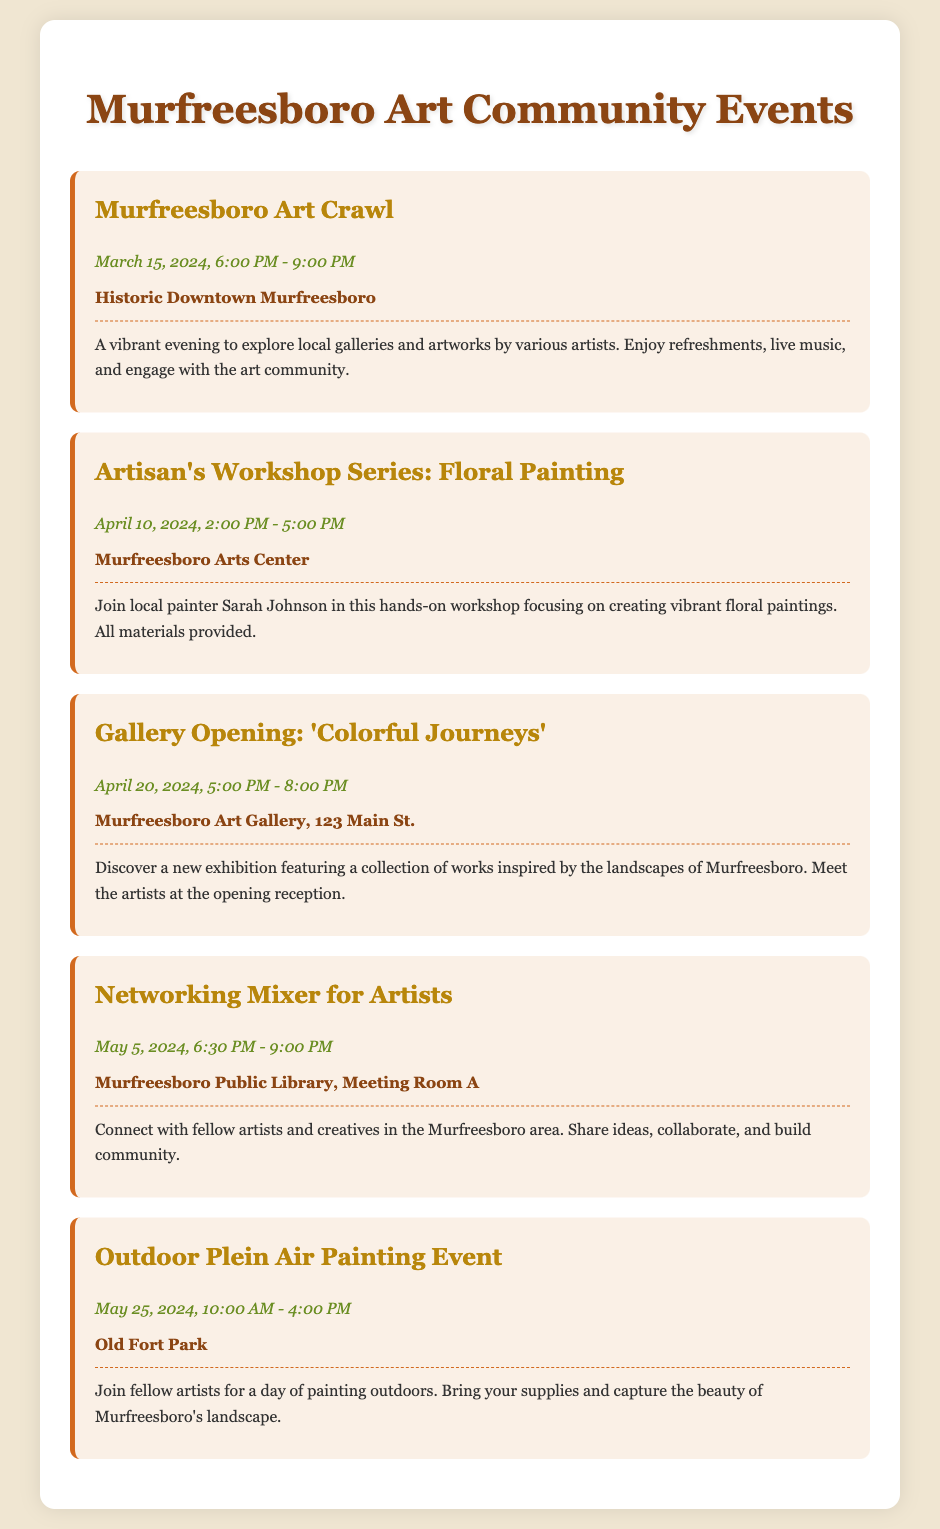What is the date of the Murfreesboro Art Crawl? The date mentioned for the Murfreesboro Art Crawl is March 15, 2024.
Answer: March 15, 2024 What is the location for the Artisan's Workshop Series? The place for the Artisan's Workshop Series is stated as Murfreesboro Arts Center.
Answer: Murfreesboro Arts Center Who is leading the Floral Painting workshop? The workshop is led by local painter Sarah Johnson.
Answer: Sarah Johnson What time does the Gallery Opening: 'Colorful Journeys' start? The Gallery Opening starts at 5:00 PM on April 20, 2024.
Answer: 5:00 PM How long is the Outdoor Plein Air Painting Event scheduled for? The event is scheduled from 10:00 AM to 4:00 PM, making it a 6-hour event.
Answer: 6 hours What is the purpose of the Networking Mixer for Artists? The goal of the mixer is to connect with fellow artists and creatives.
Answer: Connect with fellow artists Which event occurs in May 2024? There are two events listed for May 2024: the Networking Mixer and the Outdoor Plein Air Painting Event.
Answer: Networking Mixer and Outdoor Plein Air Painting Event What type of event is scheduled on April 20, 2024? The event on April 20, 2024, is a Gallery Opening titled 'Colorful Journeys'.
Answer: Gallery Opening What is the main theme of the Artisan's Workshop series? The theme of the Artisan's Workshop series is Floral Painting.
Answer: Floral Painting 